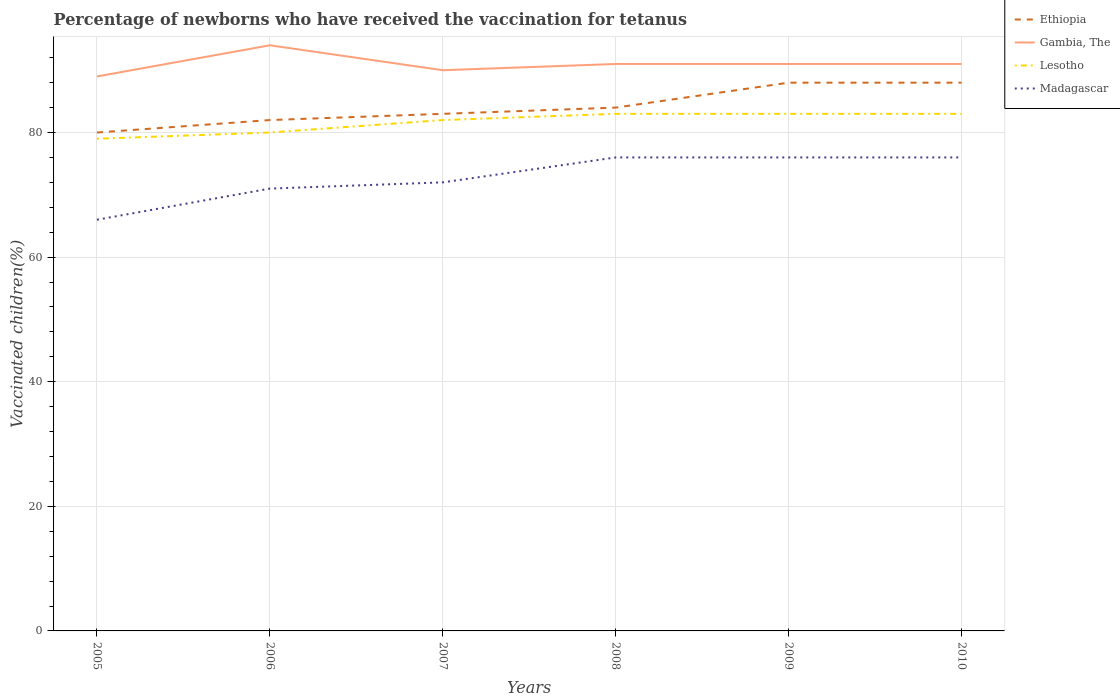Across all years, what is the maximum percentage of vaccinated children in Gambia, The?
Provide a succinct answer. 89. In which year was the percentage of vaccinated children in Gambia, The maximum?
Your answer should be very brief. 2005. What is the total percentage of vaccinated children in Gambia, The in the graph?
Make the answer very short. 0. What is the difference between the highest and the second highest percentage of vaccinated children in Gambia, The?
Your answer should be very brief. 5. How many years are there in the graph?
Offer a terse response. 6. Does the graph contain any zero values?
Make the answer very short. No. Does the graph contain grids?
Provide a short and direct response. Yes. How many legend labels are there?
Offer a very short reply. 4. What is the title of the graph?
Your answer should be very brief. Percentage of newborns who have received the vaccination for tetanus. What is the label or title of the X-axis?
Your answer should be compact. Years. What is the label or title of the Y-axis?
Keep it short and to the point. Vaccinated children(%). What is the Vaccinated children(%) of Gambia, The in 2005?
Your response must be concise. 89. What is the Vaccinated children(%) of Lesotho in 2005?
Your response must be concise. 79. What is the Vaccinated children(%) in Gambia, The in 2006?
Make the answer very short. 94. What is the Vaccinated children(%) of Lesotho in 2006?
Provide a succinct answer. 80. What is the Vaccinated children(%) in Madagascar in 2007?
Provide a short and direct response. 72. What is the Vaccinated children(%) in Ethiopia in 2008?
Offer a terse response. 84. What is the Vaccinated children(%) in Gambia, The in 2008?
Ensure brevity in your answer.  91. What is the Vaccinated children(%) in Lesotho in 2008?
Keep it short and to the point. 83. What is the Vaccinated children(%) of Gambia, The in 2009?
Offer a very short reply. 91. What is the Vaccinated children(%) in Gambia, The in 2010?
Provide a succinct answer. 91. What is the Vaccinated children(%) in Madagascar in 2010?
Give a very brief answer. 76. Across all years, what is the maximum Vaccinated children(%) in Gambia, The?
Your answer should be compact. 94. Across all years, what is the maximum Vaccinated children(%) in Lesotho?
Provide a short and direct response. 83. Across all years, what is the minimum Vaccinated children(%) of Ethiopia?
Give a very brief answer. 80. Across all years, what is the minimum Vaccinated children(%) in Gambia, The?
Offer a very short reply. 89. Across all years, what is the minimum Vaccinated children(%) of Lesotho?
Your answer should be very brief. 79. What is the total Vaccinated children(%) of Ethiopia in the graph?
Your answer should be very brief. 505. What is the total Vaccinated children(%) of Gambia, The in the graph?
Make the answer very short. 546. What is the total Vaccinated children(%) in Lesotho in the graph?
Keep it short and to the point. 490. What is the total Vaccinated children(%) of Madagascar in the graph?
Give a very brief answer. 437. What is the difference between the Vaccinated children(%) in Ethiopia in 2005 and that in 2006?
Your response must be concise. -2. What is the difference between the Vaccinated children(%) in Lesotho in 2005 and that in 2006?
Provide a succinct answer. -1. What is the difference between the Vaccinated children(%) in Ethiopia in 2005 and that in 2007?
Provide a succinct answer. -3. What is the difference between the Vaccinated children(%) of Madagascar in 2005 and that in 2007?
Provide a short and direct response. -6. What is the difference between the Vaccinated children(%) of Ethiopia in 2005 and that in 2008?
Your answer should be compact. -4. What is the difference between the Vaccinated children(%) of Madagascar in 2005 and that in 2008?
Make the answer very short. -10. What is the difference between the Vaccinated children(%) in Ethiopia in 2005 and that in 2009?
Provide a short and direct response. -8. What is the difference between the Vaccinated children(%) of Gambia, The in 2005 and that in 2009?
Offer a very short reply. -2. What is the difference between the Vaccinated children(%) of Madagascar in 2005 and that in 2009?
Provide a succinct answer. -10. What is the difference between the Vaccinated children(%) of Lesotho in 2005 and that in 2010?
Provide a succinct answer. -4. What is the difference between the Vaccinated children(%) of Lesotho in 2006 and that in 2007?
Ensure brevity in your answer.  -2. What is the difference between the Vaccinated children(%) in Gambia, The in 2006 and that in 2008?
Make the answer very short. 3. What is the difference between the Vaccinated children(%) of Lesotho in 2006 and that in 2008?
Provide a succinct answer. -3. What is the difference between the Vaccinated children(%) in Gambia, The in 2006 and that in 2009?
Give a very brief answer. 3. What is the difference between the Vaccinated children(%) in Ethiopia in 2006 and that in 2010?
Provide a short and direct response. -6. What is the difference between the Vaccinated children(%) of Lesotho in 2006 and that in 2010?
Provide a short and direct response. -3. What is the difference between the Vaccinated children(%) of Gambia, The in 2007 and that in 2008?
Offer a very short reply. -1. What is the difference between the Vaccinated children(%) in Lesotho in 2007 and that in 2008?
Provide a succinct answer. -1. What is the difference between the Vaccinated children(%) of Madagascar in 2007 and that in 2008?
Keep it short and to the point. -4. What is the difference between the Vaccinated children(%) in Gambia, The in 2007 and that in 2009?
Your answer should be very brief. -1. What is the difference between the Vaccinated children(%) in Lesotho in 2007 and that in 2009?
Ensure brevity in your answer.  -1. What is the difference between the Vaccinated children(%) of Gambia, The in 2007 and that in 2010?
Make the answer very short. -1. What is the difference between the Vaccinated children(%) of Lesotho in 2007 and that in 2010?
Provide a short and direct response. -1. What is the difference between the Vaccinated children(%) of Madagascar in 2007 and that in 2010?
Keep it short and to the point. -4. What is the difference between the Vaccinated children(%) of Madagascar in 2008 and that in 2009?
Provide a succinct answer. 0. What is the difference between the Vaccinated children(%) of Madagascar in 2008 and that in 2010?
Offer a very short reply. 0. What is the difference between the Vaccinated children(%) of Ethiopia in 2005 and the Vaccinated children(%) of Lesotho in 2006?
Provide a succinct answer. 0. What is the difference between the Vaccinated children(%) of Gambia, The in 2005 and the Vaccinated children(%) of Lesotho in 2006?
Your answer should be very brief. 9. What is the difference between the Vaccinated children(%) in Gambia, The in 2005 and the Vaccinated children(%) in Madagascar in 2006?
Provide a short and direct response. 18. What is the difference between the Vaccinated children(%) in Ethiopia in 2005 and the Vaccinated children(%) in Lesotho in 2007?
Make the answer very short. -2. What is the difference between the Vaccinated children(%) of Gambia, The in 2005 and the Vaccinated children(%) of Lesotho in 2007?
Keep it short and to the point. 7. What is the difference between the Vaccinated children(%) in Ethiopia in 2005 and the Vaccinated children(%) in Lesotho in 2008?
Provide a short and direct response. -3. What is the difference between the Vaccinated children(%) in Gambia, The in 2005 and the Vaccinated children(%) in Lesotho in 2008?
Keep it short and to the point. 6. What is the difference between the Vaccinated children(%) of Gambia, The in 2005 and the Vaccinated children(%) of Lesotho in 2009?
Give a very brief answer. 6. What is the difference between the Vaccinated children(%) of Ethiopia in 2005 and the Vaccinated children(%) of Gambia, The in 2010?
Your answer should be very brief. -11. What is the difference between the Vaccinated children(%) in Lesotho in 2005 and the Vaccinated children(%) in Madagascar in 2010?
Keep it short and to the point. 3. What is the difference between the Vaccinated children(%) in Ethiopia in 2006 and the Vaccinated children(%) in Lesotho in 2007?
Keep it short and to the point. 0. What is the difference between the Vaccinated children(%) of Ethiopia in 2006 and the Vaccinated children(%) of Madagascar in 2007?
Offer a very short reply. 10. What is the difference between the Vaccinated children(%) of Gambia, The in 2006 and the Vaccinated children(%) of Lesotho in 2007?
Your answer should be very brief. 12. What is the difference between the Vaccinated children(%) in Gambia, The in 2006 and the Vaccinated children(%) in Madagascar in 2007?
Make the answer very short. 22. What is the difference between the Vaccinated children(%) of Lesotho in 2006 and the Vaccinated children(%) of Madagascar in 2007?
Make the answer very short. 8. What is the difference between the Vaccinated children(%) in Ethiopia in 2006 and the Vaccinated children(%) in Gambia, The in 2008?
Provide a succinct answer. -9. What is the difference between the Vaccinated children(%) of Ethiopia in 2006 and the Vaccinated children(%) of Lesotho in 2008?
Offer a terse response. -1. What is the difference between the Vaccinated children(%) of Ethiopia in 2006 and the Vaccinated children(%) of Madagascar in 2008?
Provide a short and direct response. 6. What is the difference between the Vaccinated children(%) in Gambia, The in 2006 and the Vaccinated children(%) in Madagascar in 2008?
Offer a very short reply. 18. What is the difference between the Vaccinated children(%) of Lesotho in 2006 and the Vaccinated children(%) of Madagascar in 2008?
Keep it short and to the point. 4. What is the difference between the Vaccinated children(%) of Ethiopia in 2006 and the Vaccinated children(%) of Madagascar in 2009?
Offer a terse response. 6. What is the difference between the Vaccinated children(%) in Gambia, The in 2006 and the Vaccinated children(%) in Lesotho in 2009?
Make the answer very short. 11. What is the difference between the Vaccinated children(%) of Ethiopia in 2006 and the Vaccinated children(%) of Lesotho in 2010?
Provide a succinct answer. -1. What is the difference between the Vaccinated children(%) in Ethiopia in 2006 and the Vaccinated children(%) in Madagascar in 2010?
Provide a short and direct response. 6. What is the difference between the Vaccinated children(%) in Gambia, The in 2006 and the Vaccinated children(%) in Madagascar in 2010?
Your response must be concise. 18. What is the difference between the Vaccinated children(%) in Ethiopia in 2007 and the Vaccinated children(%) in Gambia, The in 2008?
Ensure brevity in your answer.  -8. What is the difference between the Vaccinated children(%) of Ethiopia in 2007 and the Vaccinated children(%) of Lesotho in 2008?
Your answer should be compact. 0. What is the difference between the Vaccinated children(%) in Ethiopia in 2007 and the Vaccinated children(%) in Madagascar in 2008?
Offer a terse response. 7. What is the difference between the Vaccinated children(%) in Lesotho in 2007 and the Vaccinated children(%) in Madagascar in 2008?
Keep it short and to the point. 6. What is the difference between the Vaccinated children(%) in Ethiopia in 2007 and the Vaccinated children(%) in Gambia, The in 2009?
Your response must be concise. -8. What is the difference between the Vaccinated children(%) in Ethiopia in 2007 and the Vaccinated children(%) in Madagascar in 2009?
Give a very brief answer. 7. What is the difference between the Vaccinated children(%) of Gambia, The in 2007 and the Vaccinated children(%) of Madagascar in 2009?
Ensure brevity in your answer.  14. What is the difference between the Vaccinated children(%) of Ethiopia in 2007 and the Vaccinated children(%) of Gambia, The in 2010?
Give a very brief answer. -8. What is the difference between the Vaccinated children(%) of Ethiopia in 2007 and the Vaccinated children(%) of Lesotho in 2010?
Provide a short and direct response. 0. What is the difference between the Vaccinated children(%) of Ethiopia in 2007 and the Vaccinated children(%) of Madagascar in 2010?
Your response must be concise. 7. What is the difference between the Vaccinated children(%) in Gambia, The in 2007 and the Vaccinated children(%) in Lesotho in 2010?
Offer a terse response. 7. What is the difference between the Vaccinated children(%) in Lesotho in 2007 and the Vaccinated children(%) in Madagascar in 2010?
Provide a short and direct response. 6. What is the difference between the Vaccinated children(%) of Ethiopia in 2008 and the Vaccinated children(%) of Gambia, The in 2009?
Give a very brief answer. -7. What is the difference between the Vaccinated children(%) of Ethiopia in 2008 and the Vaccinated children(%) of Gambia, The in 2010?
Your response must be concise. -7. What is the difference between the Vaccinated children(%) in Ethiopia in 2008 and the Vaccinated children(%) in Lesotho in 2010?
Offer a terse response. 1. What is the difference between the Vaccinated children(%) of Ethiopia in 2008 and the Vaccinated children(%) of Madagascar in 2010?
Make the answer very short. 8. What is the difference between the Vaccinated children(%) of Gambia, The in 2008 and the Vaccinated children(%) of Madagascar in 2010?
Offer a very short reply. 15. What is the difference between the Vaccinated children(%) of Lesotho in 2008 and the Vaccinated children(%) of Madagascar in 2010?
Keep it short and to the point. 7. What is the difference between the Vaccinated children(%) of Ethiopia in 2009 and the Vaccinated children(%) of Lesotho in 2010?
Give a very brief answer. 5. What is the difference between the Vaccinated children(%) of Gambia, The in 2009 and the Vaccinated children(%) of Madagascar in 2010?
Provide a succinct answer. 15. What is the difference between the Vaccinated children(%) of Lesotho in 2009 and the Vaccinated children(%) of Madagascar in 2010?
Your answer should be very brief. 7. What is the average Vaccinated children(%) of Ethiopia per year?
Keep it short and to the point. 84.17. What is the average Vaccinated children(%) in Gambia, The per year?
Give a very brief answer. 91. What is the average Vaccinated children(%) in Lesotho per year?
Provide a short and direct response. 81.67. What is the average Vaccinated children(%) of Madagascar per year?
Offer a terse response. 72.83. In the year 2005, what is the difference between the Vaccinated children(%) of Ethiopia and Vaccinated children(%) of Gambia, The?
Ensure brevity in your answer.  -9. In the year 2005, what is the difference between the Vaccinated children(%) in Ethiopia and Vaccinated children(%) in Madagascar?
Make the answer very short. 14. In the year 2005, what is the difference between the Vaccinated children(%) in Gambia, The and Vaccinated children(%) in Lesotho?
Offer a terse response. 10. In the year 2005, what is the difference between the Vaccinated children(%) in Gambia, The and Vaccinated children(%) in Madagascar?
Provide a succinct answer. 23. In the year 2006, what is the difference between the Vaccinated children(%) of Ethiopia and Vaccinated children(%) of Gambia, The?
Give a very brief answer. -12. In the year 2006, what is the difference between the Vaccinated children(%) in Ethiopia and Vaccinated children(%) in Lesotho?
Ensure brevity in your answer.  2. In the year 2006, what is the difference between the Vaccinated children(%) in Ethiopia and Vaccinated children(%) in Madagascar?
Offer a very short reply. 11. In the year 2006, what is the difference between the Vaccinated children(%) of Gambia, The and Vaccinated children(%) of Lesotho?
Make the answer very short. 14. In the year 2006, what is the difference between the Vaccinated children(%) of Gambia, The and Vaccinated children(%) of Madagascar?
Provide a short and direct response. 23. In the year 2006, what is the difference between the Vaccinated children(%) of Lesotho and Vaccinated children(%) of Madagascar?
Ensure brevity in your answer.  9. In the year 2007, what is the difference between the Vaccinated children(%) in Gambia, The and Vaccinated children(%) in Lesotho?
Keep it short and to the point. 8. In the year 2007, what is the difference between the Vaccinated children(%) of Gambia, The and Vaccinated children(%) of Madagascar?
Your answer should be very brief. 18. In the year 2007, what is the difference between the Vaccinated children(%) of Lesotho and Vaccinated children(%) of Madagascar?
Your response must be concise. 10. In the year 2008, what is the difference between the Vaccinated children(%) of Ethiopia and Vaccinated children(%) of Gambia, The?
Ensure brevity in your answer.  -7. In the year 2008, what is the difference between the Vaccinated children(%) of Gambia, The and Vaccinated children(%) of Lesotho?
Make the answer very short. 8. In the year 2008, what is the difference between the Vaccinated children(%) of Lesotho and Vaccinated children(%) of Madagascar?
Make the answer very short. 7. In the year 2009, what is the difference between the Vaccinated children(%) in Ethiopia and Vaccinated children(%) in Gambia, The?
Offer a very short reply. -3. In the year 2009, what is the difference between the Vaccinated children(%) of Ethiopia and Vaccinated children(%) of Lesotho?
Make the answer very short. 5. In the year 2009, what is the difference between the Vaccinated children(%) of Gambia, The and Vaccinated children(%) of Lesotho?
Your answer should be very brief. 8. In the year 2009, what is the difference between the Vaccinated children(%) of Lesotho and Vaccinated children(%) of Madagascar?
Provide a succinct answer. 7. In the year 2010, what is the difference between the Vaccinated children(%) of Ethiopia and Vaccinated children(%) of Gambia, The?
Your answer should be very brief. -3. In the year 2010, what is the difference between the Vaccinated children(%) of Gambia, The and Vaccinated children(%) of Lesotho?
Make the answer very short. 8. In the year 2010, what is the difference between the Vaccinated children(%) of Gambia, The and Vaccinated children(%) of Madagascar?
Your answer should be very brief. 15. In the year 2010, what is the difference between the Vaccinated children(%) of Lesotho and Vaccinated children(%) of Madagascar?
Your answer should be very brief. 7. What is the ratio of the Vaccinated children(%) of Ethiopia in 2005 to that in 2006?
Your response must be concise. 0.98. What is the ratio of the Vaccinated children(%) in Gambia, The in 2005 to that in 2006?
Keep it short and to the point. 0.95. What is the ratio of the Vaccinated children(%) of Lesotho in 2005 to that in 2006?
Offer a terse response. 0.99. What is the ratio of the Vaccinated children(%) of Madagascar in 2005 to that in 2006?
Your answer should be very brief. 0.93. What is the ratio of the Vaccinated children(%) of Ethiopia in 2005 to that in 2007?
Give a very brief answer. 0.96. What is the ratio of the Vaccinated children(%) in Gambia, The in 2005 to that in 2007?
Provide a short and direct response. 0.99. What is the ratio of the Vaccinated children(%) in Lesotho in 2005 to that in 2007?
Ensure brevity in your answer.  0.96. What is the ratio of the Vaccinated children(%) of Gambia, The in 2005 to that in 2008?
Make the answer very short. 0.98. What is the ratio of the Vaccinated children(%) in Lesotho in 2005 to that in 2008?
Offer a very short reply. 0.95. What is the ratio of the Vaccinated children(%) of Madagascar in 2005 to that in 2008?
Your response must be concise. 0.87. What is the ratio of the Vaccinated children(%) in Ethiopia in 2005 to that in 2009?
Your answer should be very brief. 0.91. What is the ratio of the Vaccinated children(%) of Lesotho in 2005 to that in 2009?
Keep it short and to the point. 0.95. What is the ratio of the Vaccinated children(%) in Madagascar in 2005 to that in 2009?
Provide a short and direct response. 0.87. What is the ratio of the Vaccinated children(%) of Ethiopia in 2005 to that in 2010?
Your response must be concise. 0.91. What is the ratio of the Vaccinated children(%) in Lesotho in 2005 to that in 2010?
Ensure brevity in your answer.  0.95. What is the ratio of the Vaccinated children(%) of Madagascar in 2005 to that in 2010?
Provide a succinct answer. 0.87. What is the ratio of the Vaccinated children(%) of Gambia, The in 2006 to that in 2007?
Make the answer very short. 1.04. What is the ratio of the Vaccinated children(%) of Lesotho in 2006 to that in 2007?
Ensure brevity in your answer.  0.98. What is the ratio of the Vaccinated children(%) in Madagascar in 2006 to that in 2007?
Your answer should be very brief. 0.99. What is the ratio of the Vaccinated children(%) of Ethiopia in 2006 to that in 2008?
Provide a succinct answer. 0.98. What is the ratio of the Vaccinated children(%) of Gambia, The in 2006 to that in 2008?
Provide a succinct answer. 1.03. What is the ratio of the Vaccinated children(%) of Lesotho in 2006 to that in 2008?
Your response must be concise. 0.96. What is the ratio of the Vaccinated children(%) of Madagascar in 2006 to that in 2008?
Keep it short and to the point. 0.93. What is the ratio of the Vaccinated children(%) of Ethiopia in 2006 to that in 2009?
Give a very brief answer. 0.93. What is the ratio of the Vaccinated children(%) in Gambia, The in 2006 to that in 2009?
Your response must be concise. 1.03. What is the ratio of the Vaccinated children(%) in Lesotho in 2006 to that in 2009?
Your answer should be very brief. 0.96. What is the ratio of the Vaccinated children(%) in Madagascar in 2006 to that in 2009?
Make the answer very short. 0.93. What is the ratio of the Vaccinated children(%) in Ethiopia in 2006 to that in 2010?
Your answer should be very brief. 0.93. What is the ratio of the Vaccinated children(%) of Gambia, The in 2006 to that in 2010?
Offer a terse response. 1.03. What is the ratio of the Vaccinated children(%) of Lesotho in 2006 to that in 2010?
Your response must be concise. 0.96. What is the ratio of the Vaccinated children(%) of Madagascar in 2006 to that in 2010?
Provide a short and direct response. 0.93. What is the ratio of the Vaccinated children(%) of Ethiopia in 2007 to that in 2008?
Your response must be concise. 0.99. What is the ratio of the Vaccinated children(%) of Lesotho in 2007 to that in 2008?
Offer a terse response. 0.99. What is the ratio of the Vaccinated children(%) in Madagascar in 2007 to that in 2008?
Offer a very short reply. 0.95. What is the ratio of the Vaccinated children(%) in Ethiopia in 2007 to that in 2009?
Keep it short and to the point. 0.94. What is the ratio of the Vaccinated children(%) of Gambia, The in 2007 to that in 2009?
Give a very brief answer. 0.99. What is the ratio of the Vaccinated children(%) of Lesotho in 2007 to that in 2009?
Your answer should be very brief. 0.99. What is the ratio of the Vaccinated children(%) in Madagascar in 2007 to that in 2009?
Ensure brevity in your answer.  0.95. What is the ratio of the Vaccinated children(%) of Ethiopia in 2007 to that in 2010?
Your response must be concise. 0.94. What is the ratio of the Vaccinated children(%) of Lesotho in 2007 to that in 2010?
Provide a short and direct response. 0.99. What is the ratio of the Vaccinated children(%) of Madagascar in 2007 to that in 2010?
Offer a very short reply. 0.95. What is the ratio of the Vaccinated children(%) of Ethiopia in 2008 to that in 2009?
Your answer should be very brief. 0.95. What is the ratio of the Vaccinated children(%) of Gambia, The in 2008 to that in 2009?
Ensure brevity in your answer.  1. What is the ratio of the Vaccinated children(%) of Lesotho in 2008 to that in 2009?
Offer a terse response. 1. What is the ratio of the Vaccinated children(%) of Ethiopia in 2008 to that in 2010?
Your response must be concise. 0.95. What is the ratio of the Vaccinated children(%) in Madagascar in 2008 to that in 2010?
Make the answer very short. 1. What is the ratio of the Vaccinated children(%) in Gambia, The in 2009 to that in 2010?
Offer a terse response. 1. What is the ratio of the Vaccinated children(%) in Lesotho in 2009 to that in 2010?
Your answer should be very brief. 1. What is the ratio of the Vaccinated children(%) in Madagascar in 2009 to that in 2010?
Ensure brevity in your answer.  1. What is the difference between the highest and the second highest Vaccinated children(%) in Lesotho?
Offer a very short reply. 0. What is the difference between the highest and the second highest Vaccinated children(%) of Madagascar?
Ensure brevity in your answer.  0. What is the difference between the highest and the lowest Vaccinated children(%) in Ethiopia?
Your response must be concise. 8. What is the difference between the highest and the lowest Vaccinated children(%) of Gambia, The?
Offer a very short reply. 5. 